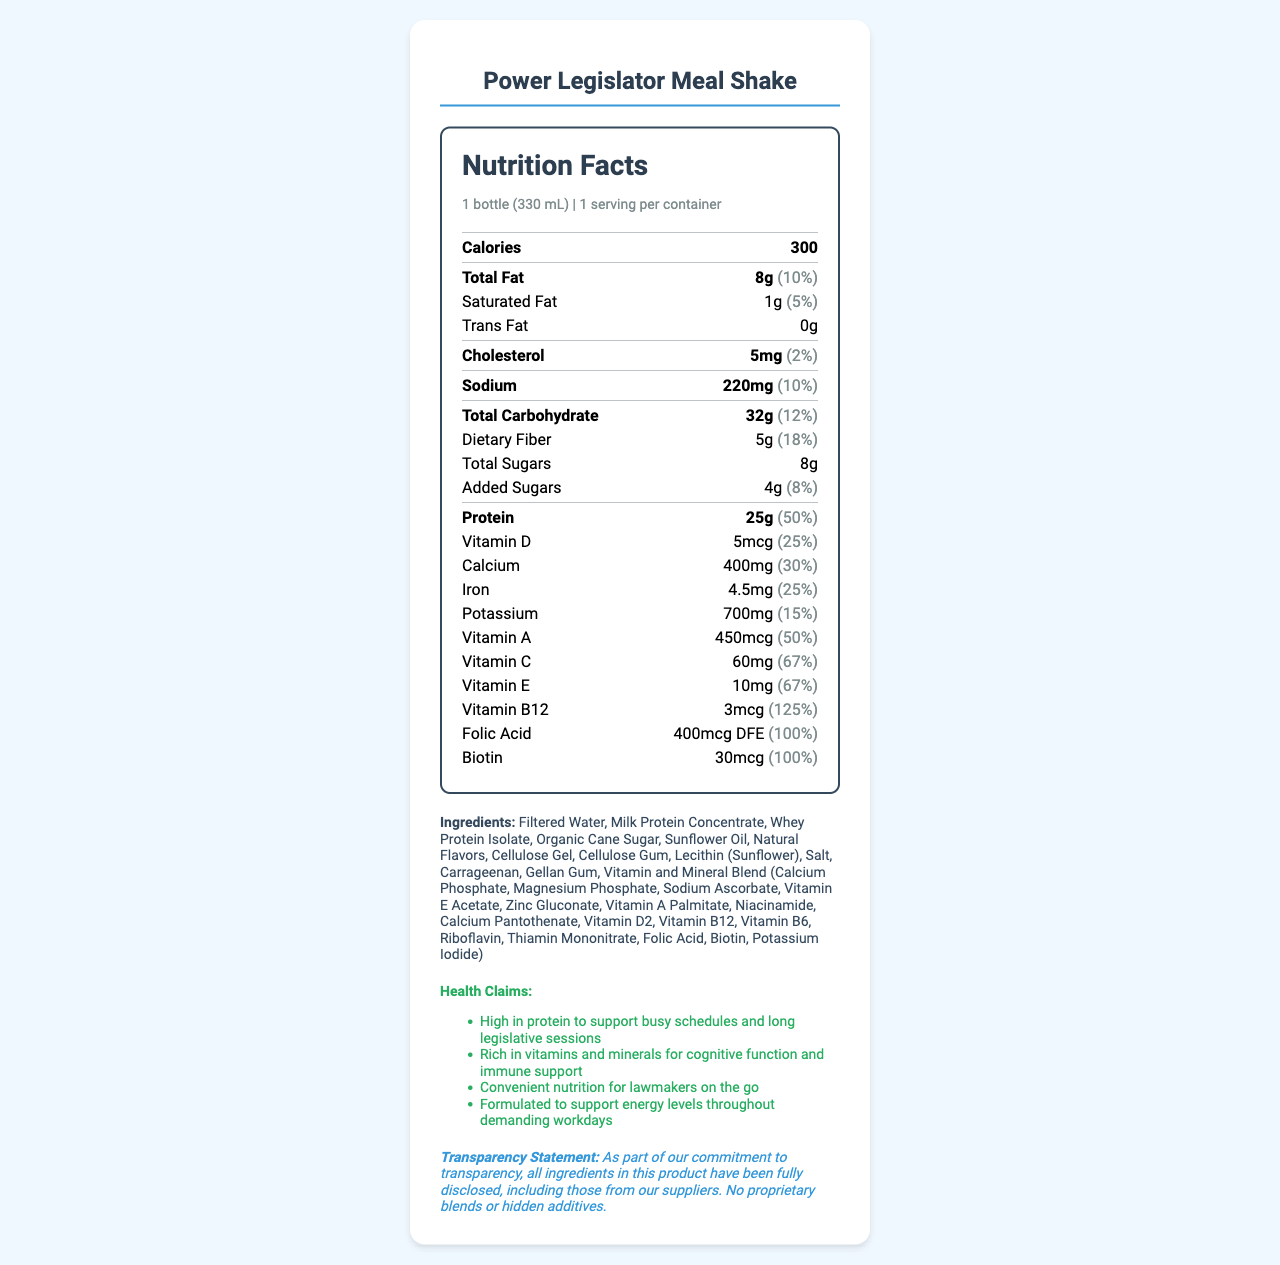what is the serving size? The serving size is clearly mentioned as "1 bottle (330 mL)" under the serving info section.
Answer: 1 bottle (330 mL) how many calories are in one serving? The document states "Calories: 300" within the nutrition facts section.
Answer: 300 how much protein does the meal replacement provide? Under the nutrient section for protein, it is mentioned that the amount is 25g.
Answer: 25g what are the main vitamins included in this shake? The document lists these vitamins explicitly under the nutrition facts section.
Answer: Vitamin D, Vitamin A, Vitamin C, Vitamin E, Vitamin B12, Folic Acid, Biotin how much dietary fiber is in one serving? The dietary fiber content is noted as 5g in the nutrient section of the nutrition facts.
Answer: 5g which of the following is not an ingredient in the Power Legislator Meal Shake? A. Whey Protein Isolate B. Soy Protein Isolate C. Organic Cane Sugar D. Natural Flavors The ingredient section lists Whey Protein Isolate, Organic Cane Sugar, and Natural Flavors, but not Soy Protein Isolate.
Answer: B. Soy Protein Isolate what percentage of the daily value for calcium does one serving provide? A. 15% B. 25% C. 30% D. 50% The document lists the daily value for calcium as 30% under the nutrition facts section.
Answer: C. 30% is there any trans fat in the meal replacement shake? The trans fat content is listed as "0g" in the nutrient section of the nutrition facts.
Answer: No what is the main purpose of the health claims mentioned in the document? The health claims section mentions that the product is high in protein for busy schedules, rich in vitamins for cognitive function and immune support, and is formulated to support energy levels.
Answer: To emphasize support for busy schedules, cognitive function, immune support, and energy levels how many milligrams of potassium are in the Power Legislator Meal Shake? The potassium amount is specified as 700mg in the nutrition facts nutrient section.
Answer: 700mg does this product contain nuts? The allergen information states the product contains milk and is produced in a facility that processes soy and tree nuts, but it does not explicitly state if nuts are an ingredient.
Answer: Cannot be determined which vitamin has the highest daily value percentage in the meal shake? The document lists the daily value percentage of Vitamin B12 as 125%, which is higher than the other vitamins listed.
Answer: Vitamin B12 what are the total carbohydrates in one serving? The total carbohydrate content is stated as 32g in the nutrient section of the nutrition facts.
Answer: 32g what is the transparency statement in the document? The transparency statement is provided towards the end of the document.
Answer: As part of our commitment to transparency, all ingredients in this product have been fully disclosed, including those from our suppliers. No proprietary blends or hidden additives. list all the health benefits claimed by this product. The health claims section lists these four specific benefits.
Answer: High in protein to support busy schedules and long legislative sessions; Rich in vitamins and minerals for cognitive function and immune support; Convenient nutrition for lawmakers on the go; Formulated to support energy levels throughout demanding workdays what type(s) of fat is included in the shake, and how much of each? The nutrient facts section lists the total fat amount as 8g, saturated fat as 1g, and trans fat as 0g.
Answer: Total Fat: 8g, Saturated Fat: 1g, Trans Fat: 0g what is the percentage daily value for vitamin C? The document notes that the daily value percentage for vitamin C is 67%.
Answer: 67% does the product contain milk protein? The ingredient list includes "Milk Protein Concentrate,” and the allergen info states "Contains milk."
Answer: Yes describe the main idea of the document. The document focuses on detailing the nutritional value, significant ingredients, health claims for cognitive and energy support, and a commitment to transparency in ingredient disclosure.
Answer: The document provides comprehensive nutritional information about the Power Legislator Meal Shake, highlighting its high protein and vitamin content, ingredients, health benefits, and commitment to transparency. It is designed as a nutritious meal replacement for busy politicians. 